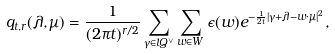<formula> <loc_0><loc_0><loc_500><loc_500>q _ { t , r } ( \lambda , \mu ) = { \frac { 1 } { ( 2 \pi t ) ^ { r / 2 } } } \sum _ { \gamma \in l Q ^ { \vee } } \sum _ { w \in W } \epsilon ( w ) e ^ { - { \frac { 1 } { 2 t } } | \gamma + \lambda - w \cdot \mu | ^ { 2 } } ,</formula> 